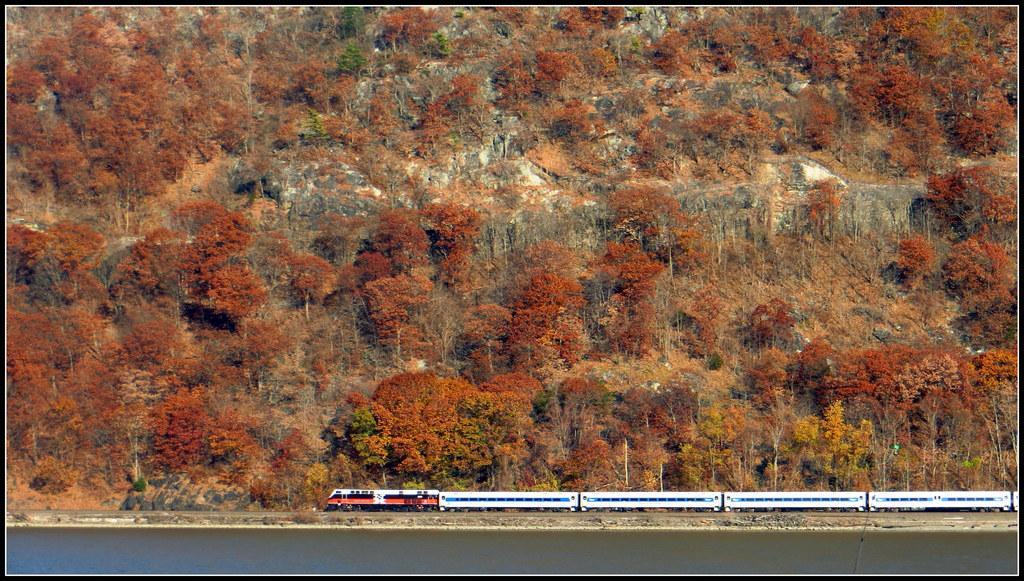Please provide a concise description of this image. In this picture there is a train and water at the bottom side of the image and there are trees and mountains in the center of the image. 